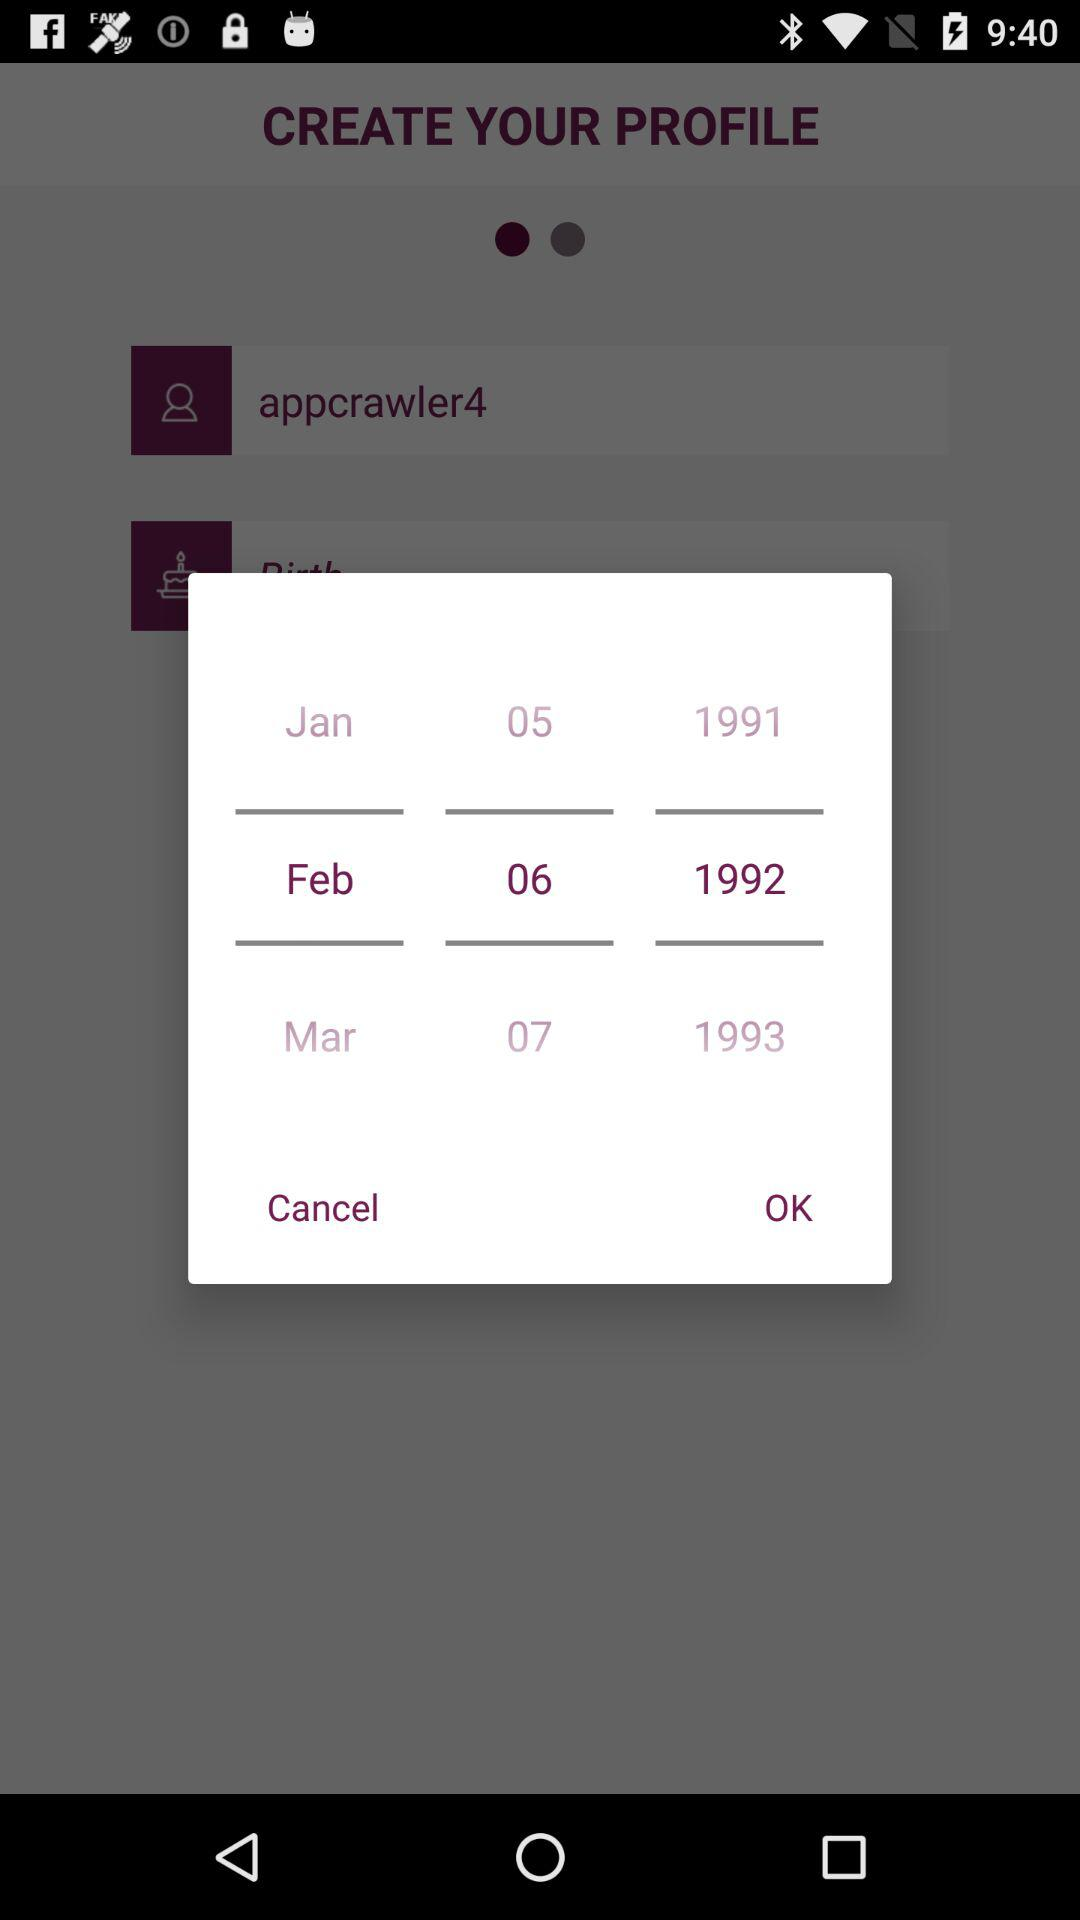How many years are represented in the 3 rows of text?
Answer the question using a single word or phrase. 3 